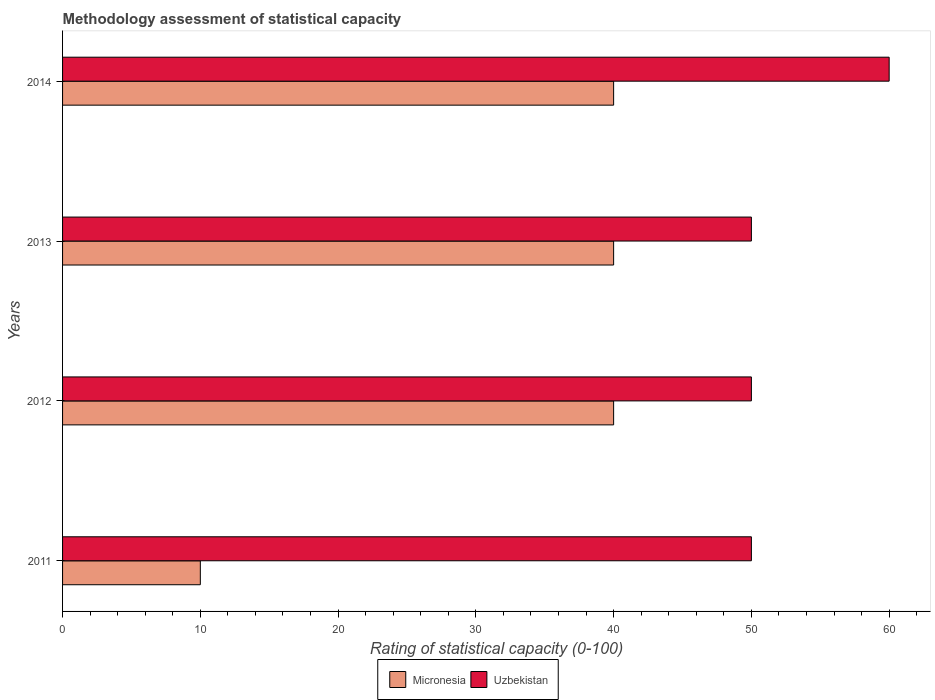How many different coloured bars are there?
Provide a short and direct response. 2. What is the label of the 3rd group of bars from the top?
Ensure brevity in your answer.  2012. In how many cases, is the number of bars for a given year not equal to the number of legend labels?
Offer a very short reply. 0. What is the rating of statistical capacity in Micronesia in 2011?
Ensure brevity in your answer.  10. Across all years, what is the maximum rating of statistical capacity in Micronesia?
Give a very brief answer. 40. What is the total rating of statistical capacity in Micronesia in the graph?
Ensure brevity in your answer.  130. What is the difference between the rating of statistical capacity in Micronesia in 2014 and the rating of statistical capacity in Uzbekistan in 2012?
Your response must be concise. -10. What is the average rating of statistical capacity in Uzbekistan per year?
Provide a short and direct response. 52.5. In the year 2011, what is the difference between the rating of statistical capacity in Uzbekistan and rating of statistical capacity in Micronesia?
Offer a very short reply. 40. In how many years, is the rating of statistical capacity in Uzbekistan greater than 44 ?
Offer a very short reply. 4. What is the ratio of the rating of statistical capacity in Micronesia in 2012 to that in 2013?
Offer a terse response. 1. Is the difference between the rating of statistical capacity in Uzbekistan in 2011 and 2014 greater than the difference between the rating of statistical capacity in Micronesia in 2011 and 2014?
Your answer should be compact. Yes. What does the 2nd bar from the top in 2014 represents?
Make the answer very short. Micronesia. What does the 2nd bar from the bottom in 2012 represents?
Offer a terse response. Uzbekistan. How many bars are there?
Keep it short and to the point. 8. Are all the bars in the graph horizontal?
Provide a short and direct response. Yes. Are the values on the major ticks of X-axis written in scientific E-notation?
Provide a short and direct response. No. How many legend labels are there?
Give a very brief answer. 2. How are the legend labels stacked?
Your answer should be very brief. Horizontal. What is the title of the graph?
Keep it short and to the point. Methodology assessment of statistical capacity. Does "Luxembourg" appear as one of the legend labels in the graph?
Your answer should be very brief. No. What is the label or title of the X-axis?
Offer a terse response. Rating of statistical capacity (0-100). What is the Rating of statistical capacity (0-100) in Micronesia in 2012?
Give a very brief answer. 40. What is the Rating of statistical capacity (0-100) of Uzbekistan in 2012?
Make the answer very short. 50. What is the Rating of statistical capacity (0-100) of Micronesia in 2014?
Give a very brief answer. 40. What is the Rating of statistical capacity (0-100) of Uzbekistan in 2014?
Give a very brief answer. 60. Across all years, what is the minimum Rating of statistical capacity (0-100) in Uzbekistan?
Offer a very short reply. 50. What is the total Rating of statistical capacity (0-100) of Micronesia in the graph?
Keep it short and to the point. 130. What is the total Rating of statistical capacity (0-100) in Uzbekistan in the graph?
Offer a terse response. 210. What is the difference between the Rating of statistical capacity (0-100) in Micronesia in 2011 and that in 2012?
Provide a short and direct response. -30. What is the difference between the Rating of statistical capacity (0-100) of Micronesia in 2011 and that in 2014?
Offer a very short reply. -30. What is the difference between the Rating of statistical capacity (0-100) in Uzbekistan in 2012 and that in 2013?
Keep it short and to the point. 0. What is the difference between the Rating of statistical capacity (0-100) in Micronesia in 2012 and that in 2014?
Your answer should be very brief. 0. What is the difference between the Rating of statistical capacity (0-100) in Uzbekistan in 2012 and that in 2014?
Your response must be concise. -10. What is the difference between the Rating of statistical capacity (0-100) in Micronesia in 2013 and that in 2014?
Provide a succinct answer. 0. What is the difference between the Rating of statistical capacity (0-100) in Uzbekistan in 2013 and that in 2014?
Provide a succinct answer. -10. What is the difference between the Rating of statistical capacity (0-100) in Micronesia in 2011 and the Rating of statistical capacity (0-100) in Uzbekistan in 2013?
Provide a short and direct response. -40. What is the difference between the Rating of statistical capacity (0-100) in Micronesia in 2011 and the Rating of statistical capacity (0-100) in Uzbekistan in 2014?
Your response must be concise. -50. What is the difference between the Rating of statistical capacity (0-100) in Micronesia in 2012 and the Rating of statistical capacity (0-100) in Uzbekistan in 2013?
Ensure brevity in your answer.  -10. What is the difference between the Rating of statistical capacity (0-100) of Micronesia in 2013 and the Rating of statistical capacity (0-100) of Uzbekistan in 2014?
Make the answer very short. -20. What is the average Rating of statistical capacity (0-100) in Micronesia per year?
Provide a succinct answer. 32.5. What is the average Rating of statistical capacity (0-100) of Uzbekistan per year?
Provide a short and direct response. 52.5. In the year 2011, what is the difference between the Rating of statistical capacity (0-100) of Micronesia and Rating of statistical capacity (0-100) of Uzbekistan?
Keep it short and to the point. -40. In the year 2012, what is the difference between the Rating of statistical capacity (0-100) in Micronesia and Rating of statistical capacity (0-100) in Uzbekistan?
Offer a terse response. -10. In the year 2014, what is the difference between the Rating of statistical capacity (0-100) of Micronesia and Rating of statistical capacity (0-100) of Uzbekistan?
Make the answer very short. -20. What is the ratio of the Rating of statistical capacity (0-100) in Uzbekistan in 2011 to that in 2012?
Your response must be concise. 1. What is the ratio of the Rating of statistical capacity (0-100) of Micronesia in 2011 to that in 2013?
Keep it short and to the point. 0.25. What is the ratio of the Rating of statistical capacity (0-100) in Uzbekistan in 2012 to that in 2013?
Ensure brevity in your answer.  1. What is the ratio of the Rating of statistical capacity (0-100) in Micronesia in 2012 to that in 2014?
Provide a succinct answer. 1. What is the ratio of the Rating of statistical capacity (0-100) of Uzbekistan in 2013 to that in 2014?
Ensure brevity in your answer.  0.83. What is the difference between the highest and the second highest Rating of statistical capacity (0-100) of Uzbekistan?
Keep it short and to the point. 10. What is the difference between the highest and the lowest Rating of statistical capacity (0-100) in Micronesia?
Offer a terse response. 30. 